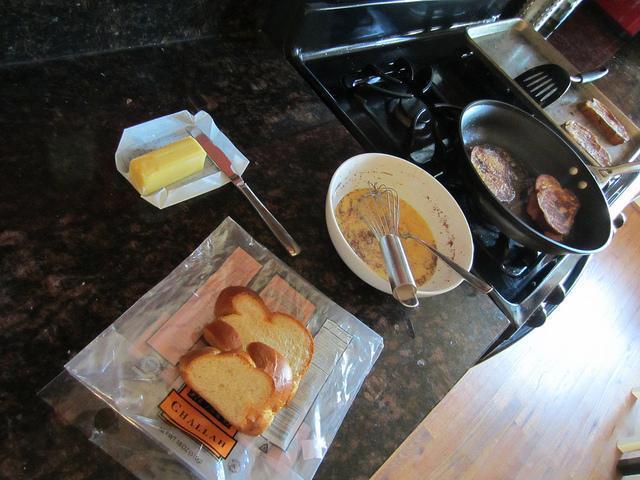How many bowls are there?
Give a very brief answer. 1. 